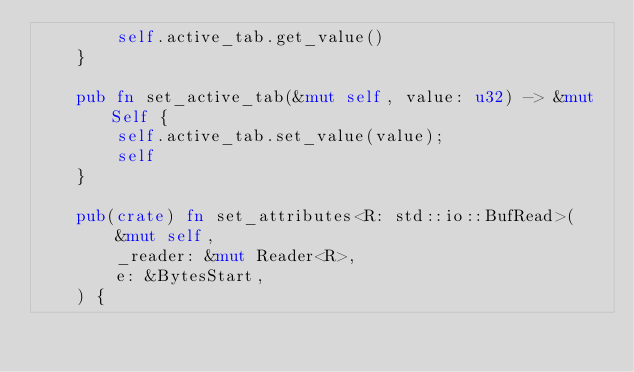Convert code to text. <code><loc_0><loc_0><loc_500><loc_500><_Rust_>        self.active_tab.get_value()
    }

    pub fn set_active_tab(&mut self, value: u32) -> &mut Self {
        self.active_tab.set_value(value);
        self
    }

    pub(crate) fn set_attributes<R: std::io::BufRead>(
        &mut self,
        _reader: &mut Reader<R>,
        e: &BytesStart,
    ) {</code> 